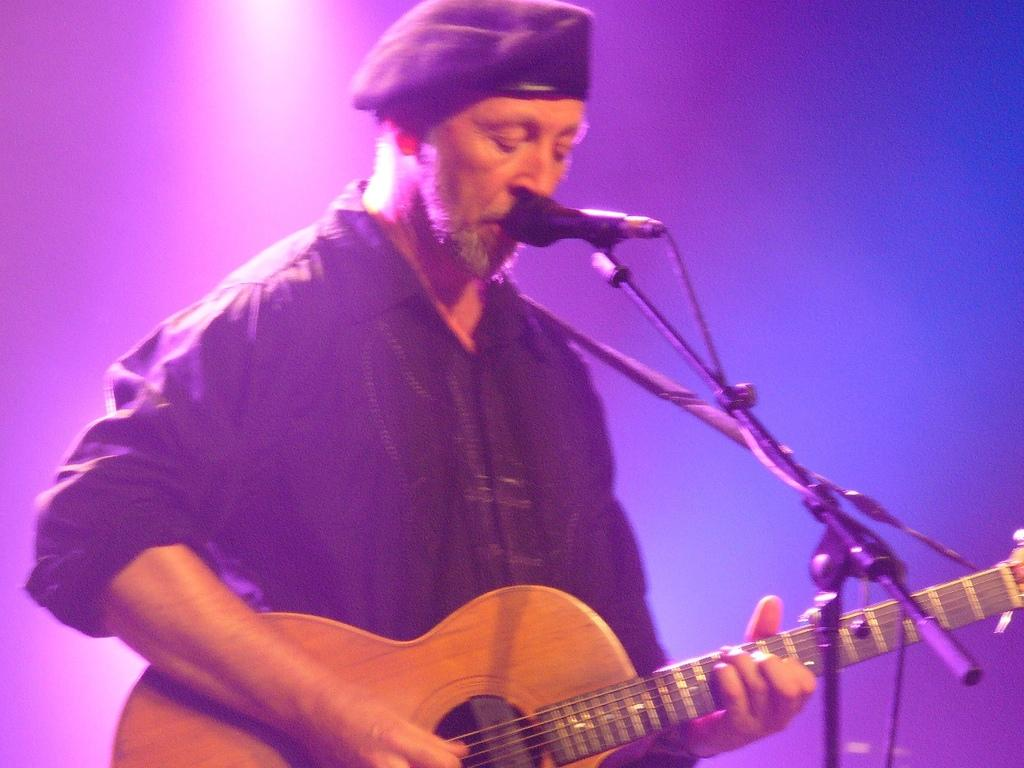Where is the person in the image located? The person is standing on a stage. What is the person holding in the image? The person is holding a guitar. What is the person doing with the guitar? The person is playing the guitar. What is the person doing while playing the guitar? The person is singing a song. What type of headwear is the person wearing? The person is wearing a cap. How many screws can be seen on the guitar in the image? There are no screws visible on the guitar in the image. 